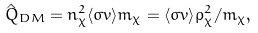Convert formula to latex. <formula><loc_0><loc_0><loc_500><loc_500>\hat { Q } _ { D M } = n _ { \chi } ^ { 2 } \langle \sigma v \rangle m _ { \chi } = \langle \sigma v \rangle \rho _ { \chi } ^ { 2 } / m _ { \chi } ,</formula> 